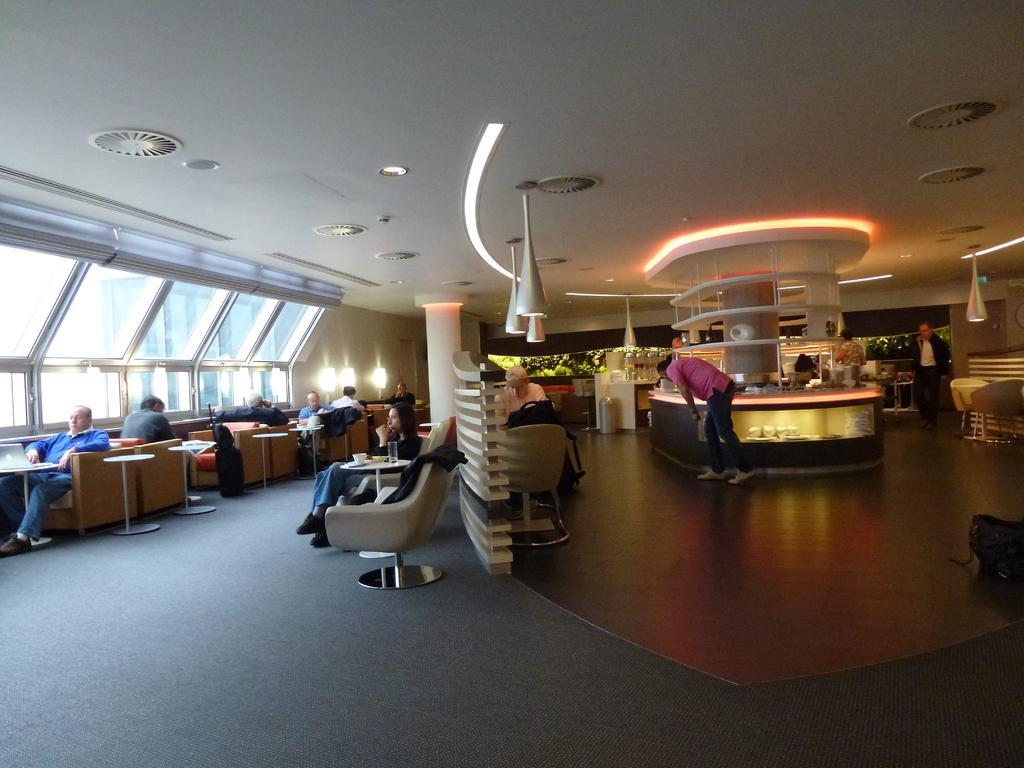Could you give a brief overview of what you see in this image? In the picture we can see a hall with some chairs and tables and beside it, we can see a glass wall and in the middle of the floor, we can see a desk with a person standing near it and on the ceiling we can see some lights. 